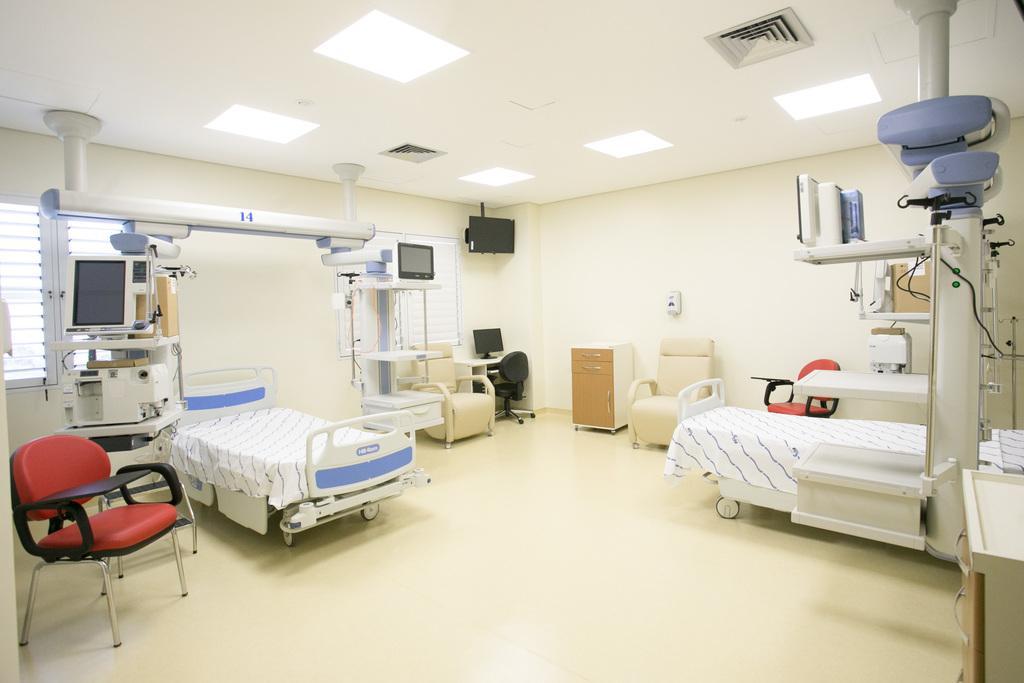Please provide a concise description of this image. In the picture we can see a hospital room with a bed on some stretcher fixed to it and beside we can see a computer equipment and a chair which is red in color and to the wall we can see a television and under it on the floor, we can see a cupboard and besides we can see a chair and a bed, on the ceiling we can see some lights and air conditioners. 